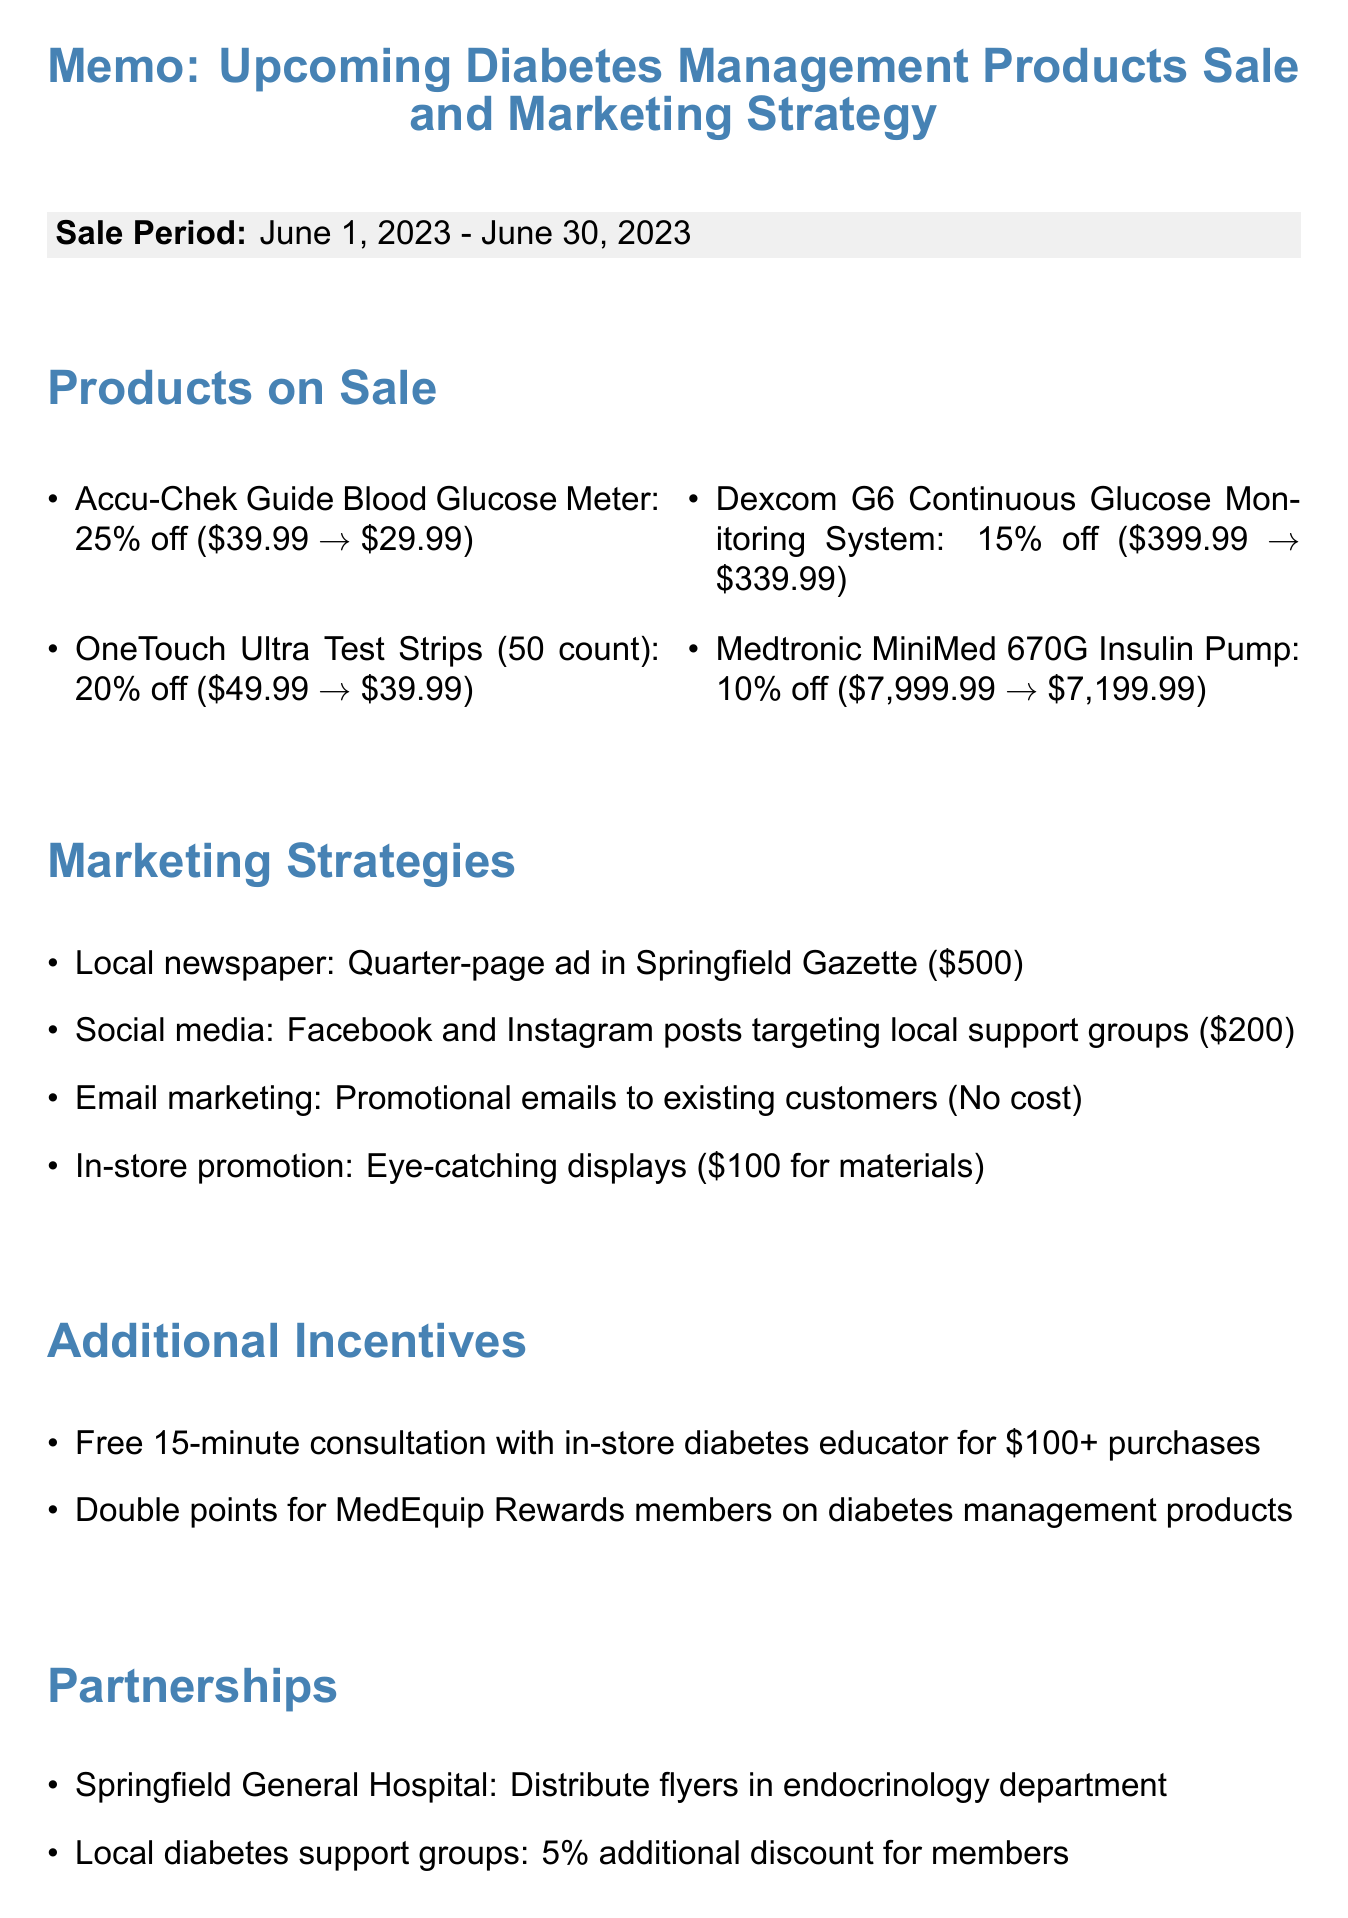What is the date range for the sale? The date range for the sale is specified in the sale period section of the document, running from June 1, 2023 to June 30, 2023.
Answer: June 1, 2023 - June 30, 2023 What product has the highest discount? The product with the highest discount can be found by comparing the discounts listed, where the Accu-Chek Guide Blood Glucose Meter offers a 25% discount.
Answer: Accu-Chek Guide Blood Glucose Meter How much does the Dexcom G6 cost after discount? The sale price for the Dexcom G6 Continuous Glucose Monitoring System is given in the products on sale section, which is $339.99.
Answer: $339.99 What is the budget for the local newspaper ad? The budget for the local newspaper ad is provided in the marketing strategies section, which is $500.
Answer: $500 What is one additional incentive offered during the sale? An additional incentive is mentioned in the additional incentives section, such as a free consultation for purchases over $100.
Answer: Free consultation How many new customers does the promotion aim to attract? The expected outcomes section states the goal for new customers to be attracted during the promotion.
Answer: 50 new customers What type of display materials will be used in-store? The in-store promotion section mentions that eye-catching displays will be created, which requires printing materials costing $100.
Answer: Eye-catching displays Which hospital is mentioned as a partner? The partnerships section indicates that Springfield General Hospital is a partner for the sale.
Answer: Springfield General Hospital What are staff expected to prepare for the sale? The staff preparation section outlines the tasks for staff preparation, which includes training on product features and benefits.
Answer: Training on features and benefits of sale products 